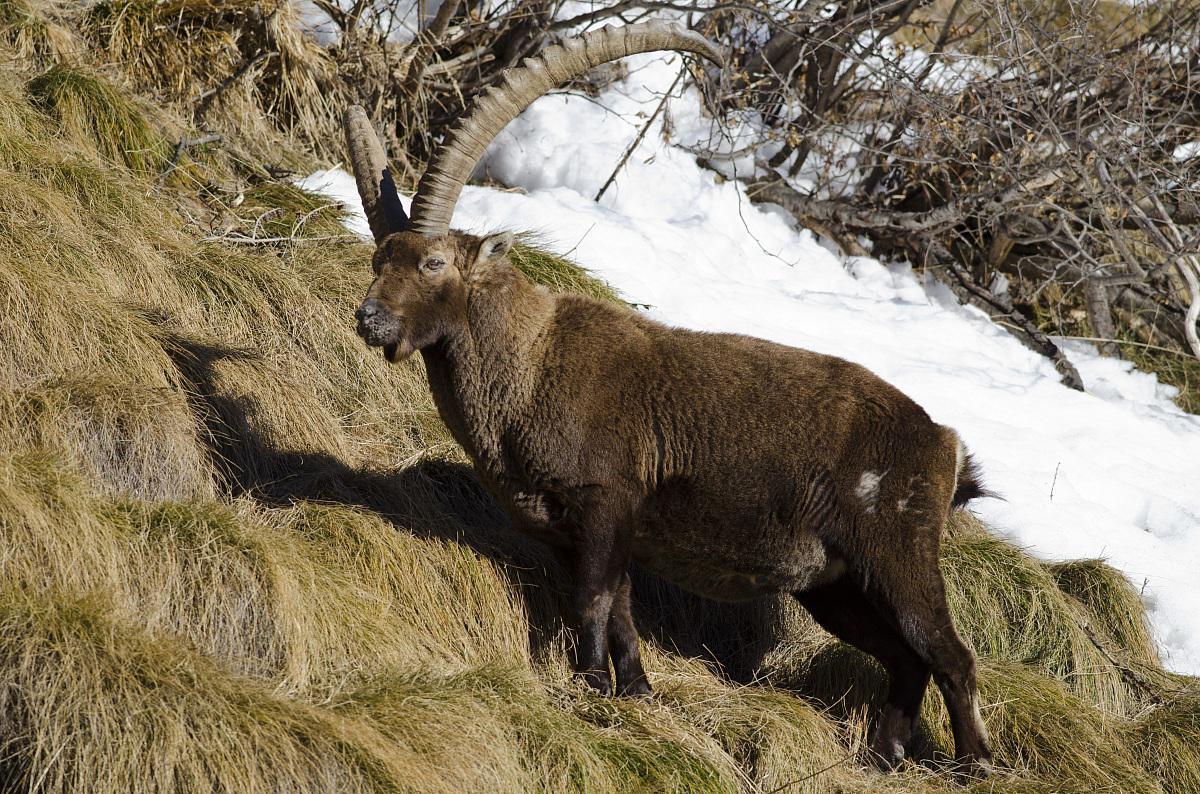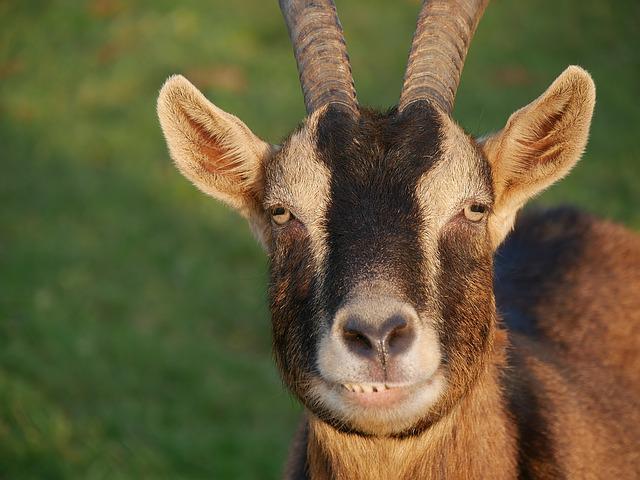The first image is the image on the left, the second image is the image on the right. Examine the images to the left and right. Is the description "One goat has its head down to the grass, while another goat is looking straight ahead." accurate? Answer yes or no. No. The first image is the image on the left, the second image is the image on the right. Given the left and right images, does the statement "The horned animals in the right and left images face the same general direction, and at least one animal is reclining on the ground." hold true? Answer yes or no. No. 